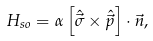<formula> <loc_0><loc_0><loc_500><loc_500>H _ { s o } = \alpha \left [ \hat { \vec { \sigma } } \times \hat { \vec { p } } \right ] \cdot \vec { n } ,</formula> 